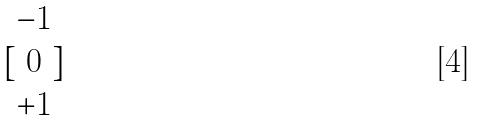Convert formula to latex. <formula><loc_0><loc_0><loc_500><loc_500>[ \begin{matrix} - 1 \\ 0 \\ + 1 \end{matrix} ]</formula> 